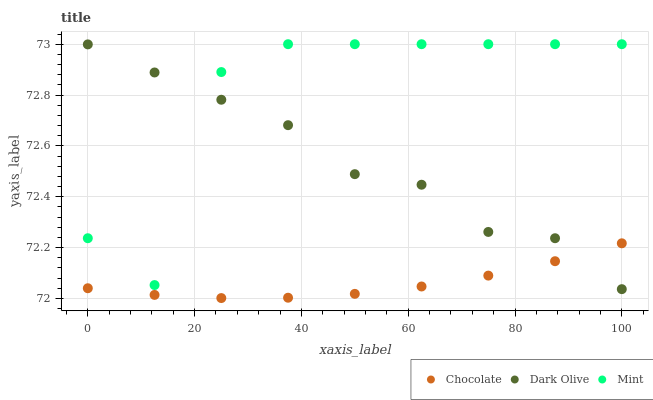Does Chocolate have the minimum area under the curve?
Answer yes or no. Yes. Does Mint have the maximum area under the curve?
Answer yes or no. Yes. Does Mint have the minimum area under the curve?
Answer yes or no. No. Does Chocolate have the maximum area under the curve?
Answer yes or no. No. Is Chocolate the smoothest?
Answer yes or no. Yes. Is Mint the roughest?
Answer yes or no. Yes. Is Mint the smoothest?
Answer yes or no. No. Is Chocolate the roughest?
Answer yes or no. No. Does Chocolate have the lowest value?
Answer yes or no. Yes. Does Mint have the lowest value?
Answer yes or no. No. Does Mint have the highest value?
Answer yes or no. Yes. Does Chocolate have the highest value?
Answer yes or no. No. Is Chocolate less than Mint?
Answer yes or no. Yes. Is Mint greater than Chocolate?
Answer yes or no. Yes. Does Chocolate intersect Dark Olive?
Answer yes or no. Yes. Is Chocolate less than Dark Olive?
Answer yes or no. No. Is Chocolate greater than Dark Olive?
Answer yes or no. No. Does Chocolate intersect Mint?
Answer yes or no. No. 